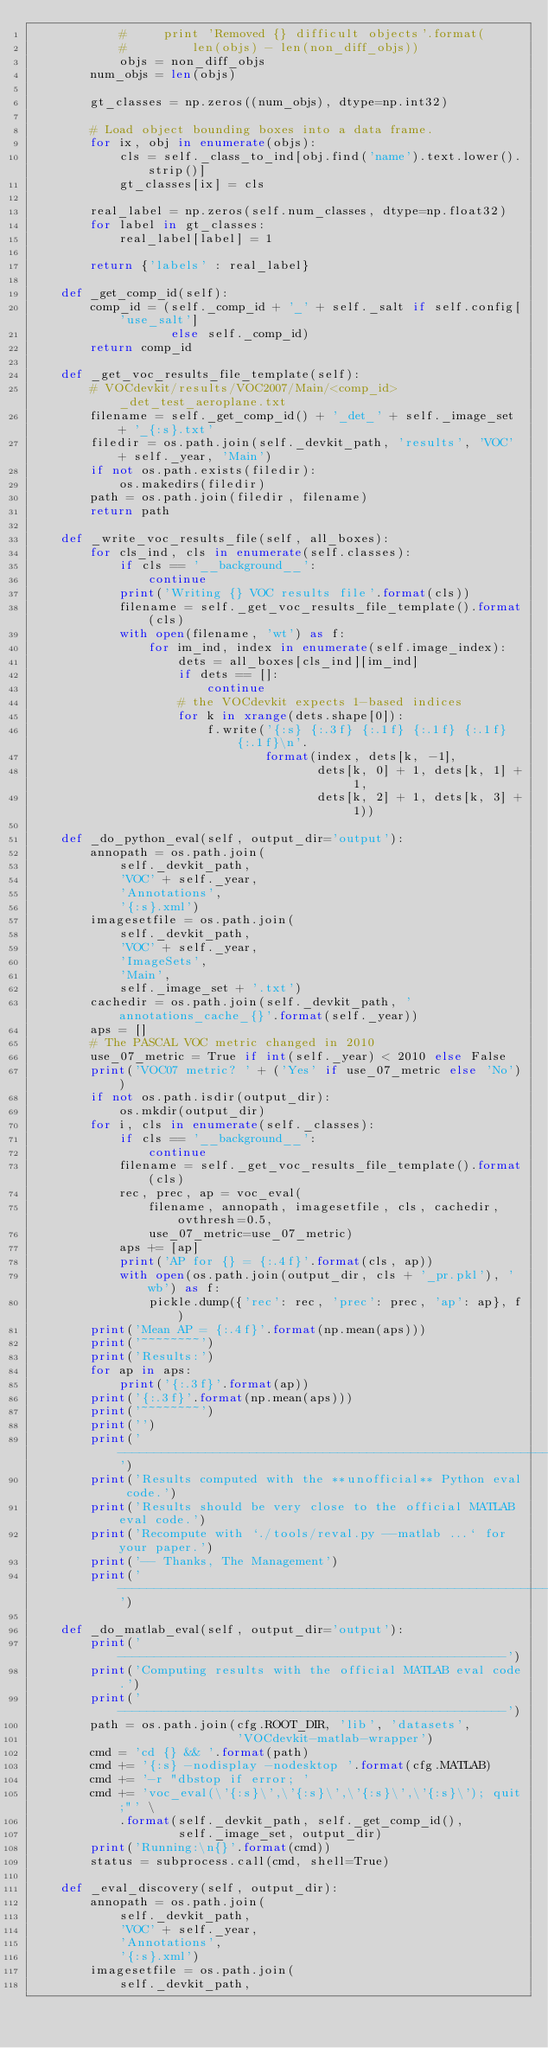<code> <loc_0><loc_0><loc_500><loc_500><_Python_>            #     print 'Removed {} difficult objects'.format(
            #         len(objs) - len(non_diff_objs))
            objs = non_diff_objs
        num_objs = len(objs)

        gt_classes = np.zeros((num_objs), dtype=np.int32)

        # Load object bounding boxes into a data frame.
        for ix, obj in enumerate(objs):
            cls = self._class_to_ind[obj.find('name').text.lower().strip()]
            gt_classes[ix] = cls

        real_label = np.zeros(self.num_classes, dtype=np.float32)
        for label in gt_classes:
            real_label[label] = 1

        return {'labels' : real_label}

    def _get_comp_id(self):
        comp_id = (self._comp_id + '_' + self._salt if self.config['use_salt']
                   else self._comp_id)
        return comp_id

    def _get_voc_results_file_template(self):
        # VOCdevkit/results/VOC2007/Main/<comp_id>_det_test_aeroplane.txt
        filename = self._get_comp_id() + '_det_' + self._image_set + '_{:s}.txt'
        filedir = os.path.join(self._devkit_path, 'results', 'VOC' + self._year, 'Main')
        if not os.path.exists(filedir):
            os.makedirs(filedir)
        path = os.path.join(filedir, filename)
        return path

    def _write_voc_results_file(self, all_boxes):
        for cls_ind, cls in enumerate(self.classes):
            if cls == '__background__':
                continue
            print('Writing {} VOC results file'.format(cls))
            filename = self._get_voc_results_file_template().format(cls)
            with open(filename, 'wt') as f:
                for im_ind, index in enumerate(self.image_index):
                    dets = all_boxes[cls_ind][im_ind]
                    if dets == []:
                        continue
                    # the VOCdevkit expects 1-based indices
                    for k in xrange(dets.shape[0]):
                        f.write('{:s} {:.3f} {:.1f} {:.1f} {:.1f} {:.1f}\n'.
                                format(index, dets[k, -1],
                                       dets[k, 0] + 1, dets[k, 1] + 1,
                                       dets[k, 2] + 1, dets[k, 3] + 1))

    def _do_python_eval(self, output_dir='output'):
        annopath = os.path.join(
            self._devkit_path,
            'VOC' + self._year,
            'Annotations',
            '{:s}.xml')
        imagesetfile = os.path.join(
            self._devkit_path,
            'VOC' + self._year,
            'ImageSets',
            'Main',
            self._image_set + '.txt')
        cachedir = os.path.join(self._devkit_path, 'annotations_cache_{}'.format(self._year))
        aps = []
        # The PASCAL VOC metric changed in 2010
        use_07_metric = True if int(self._year) < 2010 else False
        print('VOC07 metric? ' + ('Yes' if use_07_metric else 'No'))
        if not os.path.isdir(output_dir):
            os.mkdir(output_dir)
        for i, cls in enumerate(self._classes):
            if cls == '__background__':
                continue
            filename = self._get_voc_results_file_template().format(cls)
            rec, prec, ap = voc_eval(
                filename, annopath, imagesetfile, cls, cachedir, ovthresh=0.5,
                use_07_metric=use_07_metric)
            aps += [ap]
            print('AP for {} = {:.4f}'.format(cls, ap))
            with open(os.path.join(output_dir, cls + '_pr.pkl'), 'wb') as f:
                pickle.dump({'rec': rec, 'prec': prec, 'ap': ap}, f)
        print('Mean AP = {:.4f}'.format(np.mean(aps)))
        print('~~~~~~~~')
        print('Results:')
        for ap in aps:
            print('{:.3f}'.format(ap))
        print('{:.3f}'.format(np.mean(aps)))
        print('~~~~~~~~')
        print('')
        print('--------------------------------------------------------------')
        print('Results computed with the **unofficial** Python eval code.')
        print('Results should be very close to the official MATLAB eval code.')
        print('Recompute with `./tools/reval.py --matlab ...` for your paper.')
        print('-- Thanks, The Management')
        print('--------------------------------------------------------------')

    def _do_matlab_eval(self, output_dir='output'):
        print('-----------------------------------------------------')
        print('Computing results with the official MATLAB eval code.')
        print('-----------------------------------------------------')
        path = os.path.join(cfg.ROOT_DIR, 'lib', 'datasets',
                            'VOCdevkit-matlab-wrapper')
        cmd = 'cd {} && '.format(path)
        cmd += '{:s} -nodisplay -nodesktop '.format(cfg.MATLAB)
        cmd += '-r "dbstop if error; '
        cmd += 'voc_eval(\'{:s}\',\'{:s}\',\'{:s}\',\'{:s}\'); quit;"' \
            .format(self._devkit_path, self._get_comp_id(),
                    self._image_set, output_dir)
        print('Running:\n{}'.format(cmd))
        status = subprocess.call(cmd, shell=True)

    def _eval_discovery(self, output_dir):
        annopath = os.path.join(
            self._devkit_path,
            'VOC' + self._year,
            'Annotations',
            '{:s}.xml')
        imagesetfile = os.path.join(
            self._devkit_path,</code> 